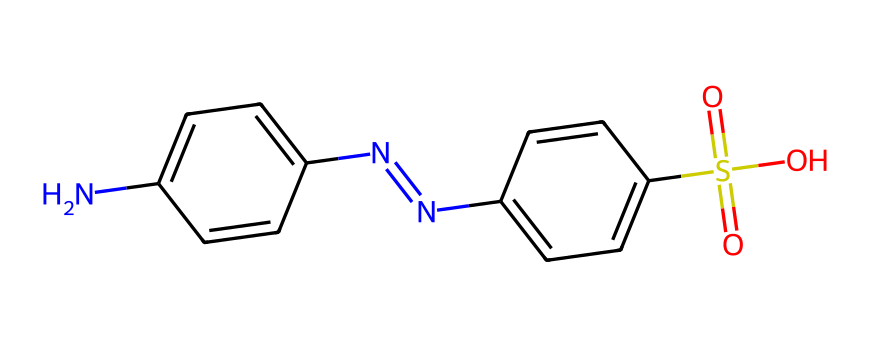What is the major functional group in this chemical? The major functional group present in this chemical is the sulfonic acid group, identifiable by the presence of the -SO3H moiety in the structure.
Answer: sulfonic acid How many nitrogen atoms are in this structure? By analyzing the SMILES representation, we can count two nitrogen atoms present in this chemical, one in the amine group (-NH2) and one in the azo linkage (N=N).
Answer: two What is the total number of aromatic rings in this chemical? In the provided SMILES structure, there are two aromatic rings, indicated by the 'c' (aromatic carbon) notation that forms part of the benzene-like structures.
Answer: two What type of chemical is this compound classified as? This compound is classified as a dye, specifically an azo dye, as indicated by the presence of the azo linkage (N=N) which is characteristic of azo dyes used for coloring applications.
Answer: azo dye What color is typically associated with azo dyes? Azo dyes are commonly associated with vibrant colors, often red or yellow, due to their electronic structure and ability to absorb light in the visible spectrum.
Answer: vibrant colors 